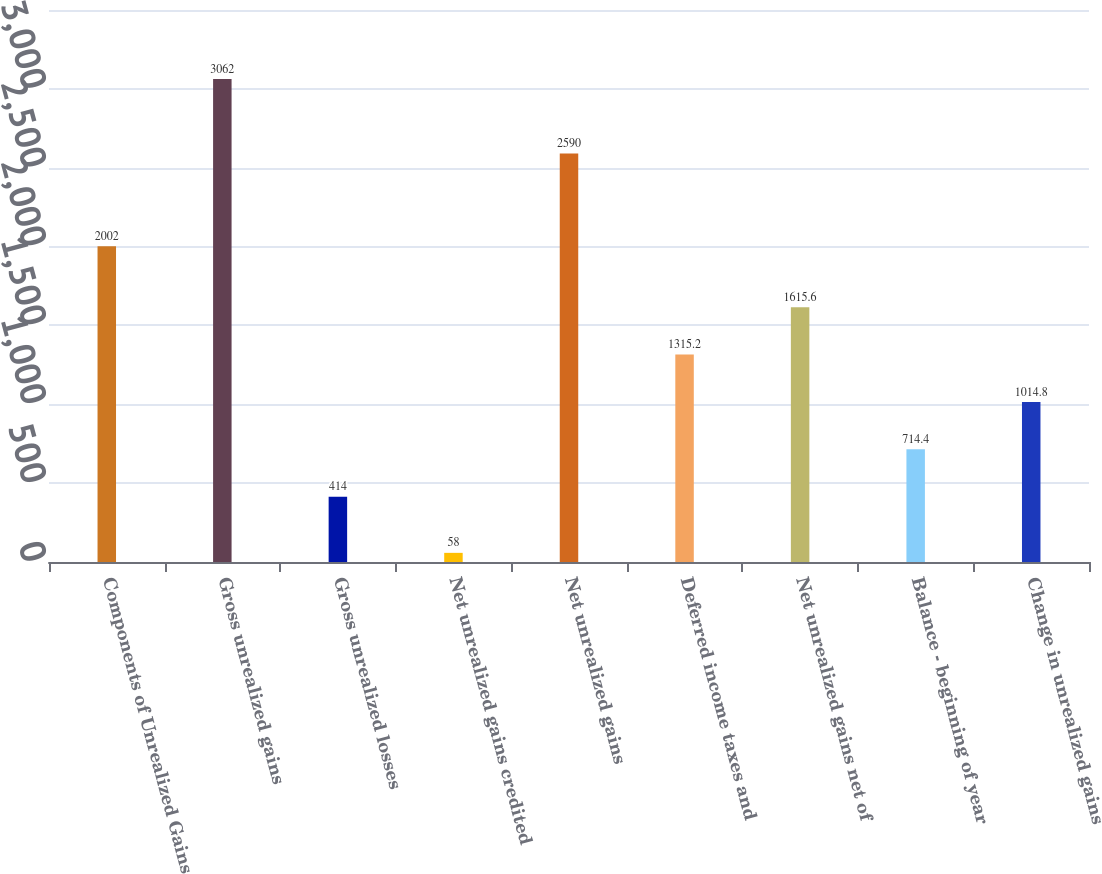<chart> <loc_0><loc_0><loc_500><loc_500><bar_chart><fcel>Components of Unrealized Gains<fcel>Gross unrealized gains<fcel>Gross unrealized losses<fcel>Net unrealized gains credited<fcel>Net unrealized gains<fcel>Deferred income taxes and<fcel>Net unrealized gains net of<fcel>Balance - beginning of year<fcel>Change in unrealized gains<nl><fcel>2002<fcel>3062<fcel>414<fcel>58<fcel>2590<fcel>1315.2<fcel>1615.6<fcel>714.4<fcel>1014.8<nl></chart> 